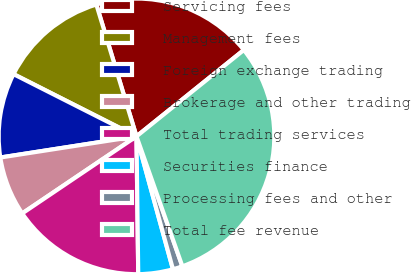<chart> <loc_0><loc_0><loc_500><loc_500><pie_chart><fcel>Servicing fees<fcel>Management fees<fcel>Foreign exchange trading<fcel>Brokerage and other trading<fcel>Total trading services<fcel>Securities finance<fcel>Processing fees and other<fcel>Total fee revenue<nl><fcel>18.92%<fcel>12.84%<fcel>9.91%<fcel>6.99%<fcel>15.76%<fcel>4.06%<fcel>1.14%<fcel>30.38%<nl></chart> 